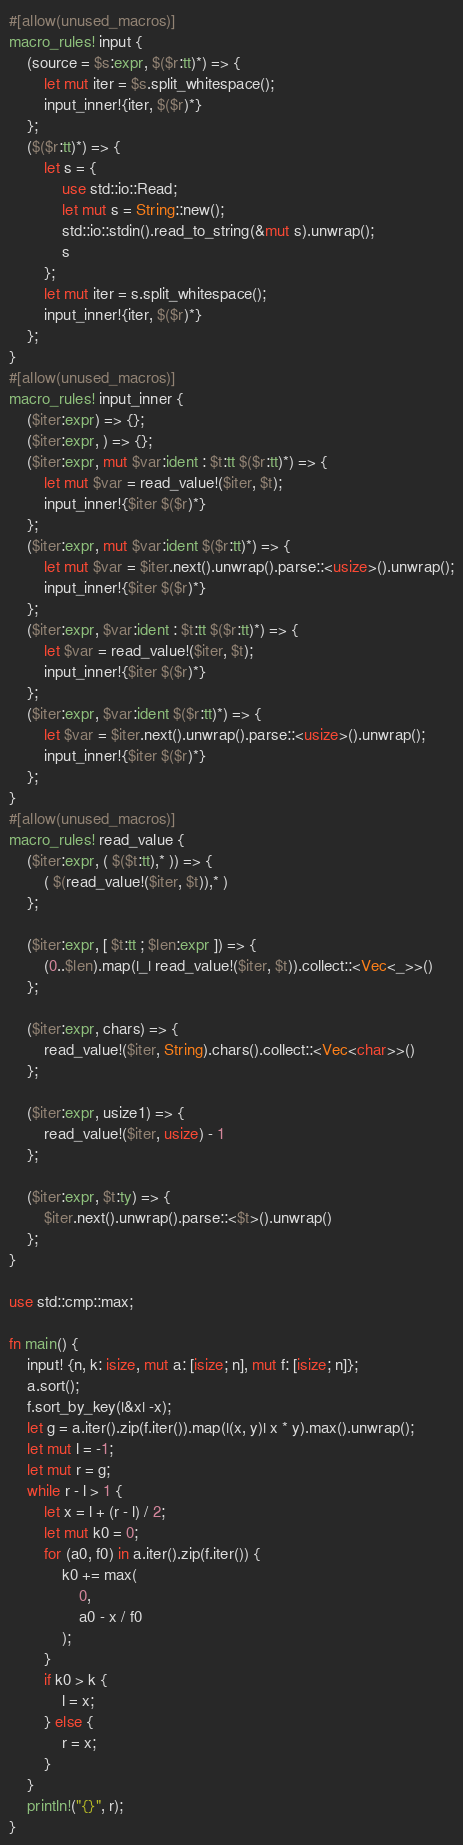Convert code to text. <code><loc_0><loc_0><loc_500><loc_500><_Rust_>#[allow(unused_macros)]
macro_rules! input {
    (source = $s:expr, $($r:tt)*) => {
        let mut iter = $s.split_whitespace();
        input_inner!{iter, $($r)*}
    };
    ($($r:tt)*) => {
        let s = {
            use std::io::Read;
            let mut s = String::new();
            std::io::stdin().read_to_string(&mut s).unwrap();
            s
        };
        let mut iter = s.split_whitespace();
        input_inner!{iter, $($r)*}
    };
}
#[allow(unused_macros)]
macro_rules! input_inner {
    ($iter:expr) => {};
    ($iter:expr, ) => {};
    ($iter:expr, mut $var:ident : $t:tt $($r:tt)*) => {
        let mut $var = read_value!($iter, $t);
        input_inner!{$iter $($r)*}
    };
    ($iter:expr, mut $var:ident $($r:tt)*) => {
        let mut $var = $iter.next().unwrap().parse::<usize>().unwrap();
        input_inner!{$iter $($r)*}
    };
    ($iter:expr, $var:ident : $t:tt $($r:tt)*) => {
        let $var = read_value!($iter, $t);
        input_inner!{$iter $($r)*}
    };
    ($iter:expr, $var:ident $($r:tt)*) => {
        let $var = $iter.next().unwrap().parse::<usize>().unwrap();
        input_inner!{$iter $($r)*}
    };
}
#[allow(unused_macros)]
macro_rules! read_value {
    ($iter:expr, ( $($t:tt),* )) => {
        ( $(read_value!($iter, $t)),* )
    };

    ($iter:expr, [ $t:tt ; $len:expr ]) => {
        (0..$len).map(|_| read_value!($iter, $t)).collect::<Vec<_>>()
    };

    ($iter:expr, chars) => {
        read_value!($iter, String).chars().collect::<Vec<char>>()
    };

    ($iter:expr, usize1) => {
        read_value!($iter, usize) - 1
    };

    ($iter:expr, $t:ty) => {
        $iter.next().unwrap().parse::<$t>().unwrap()
    };
}

use std::cmp::max;

fn main() {
    input! {n, k: isize, mut a: [isize; n], mut f: [isize; n]};
    a.sort();
    f.sort_by_key(|&x| -x);
    let g = a.iter().zip(f.iter()).map(|(x, y)| x * y).max().unwrap();
    let mut l = -1;
    let mut r = g;
    while r - l > 1 {
        let x = l + (r - l) / 2;
        let mut k0 = 0;
        for (a0, f0) in a.iter().zip(f.iter()) {
            k0 += max(
                0,
                a0 - x / f0
            );
        }
        if k0 > k {
            l = x;
        } else {
            r = x;
        }
    }
    println!("{}", r);
}</code> 